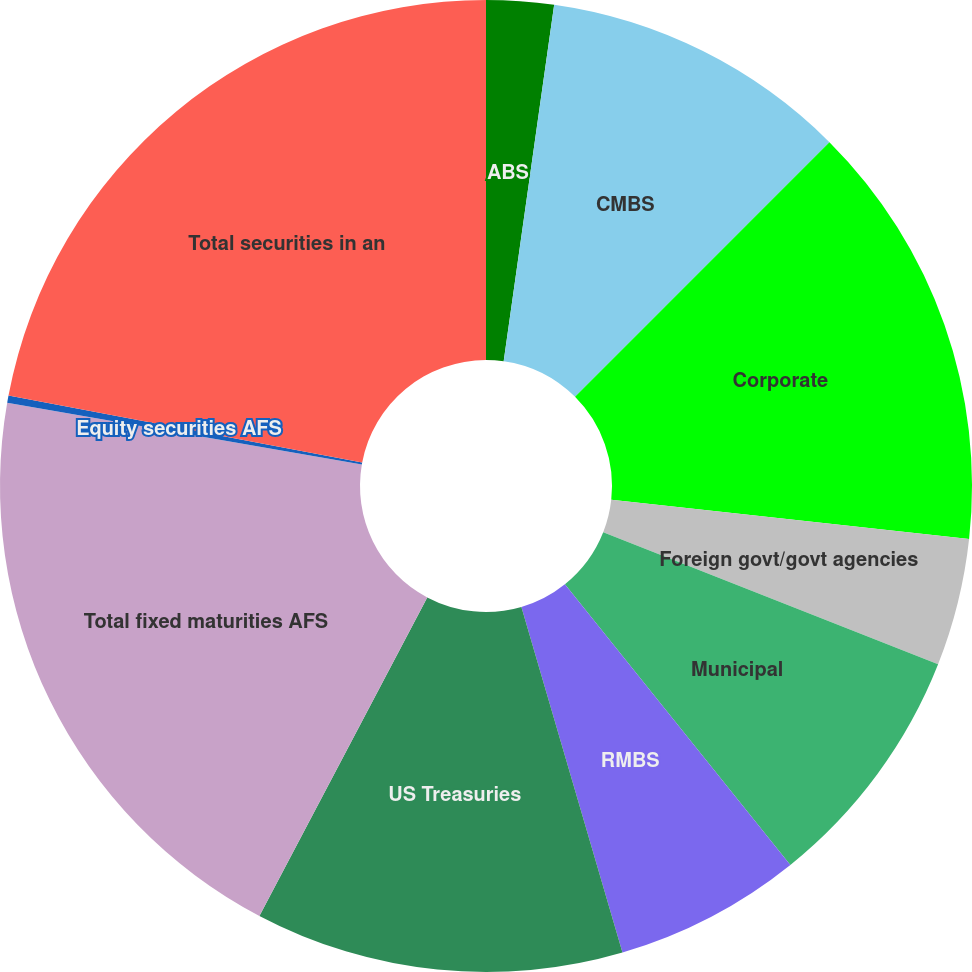Convert chart to OTSL. <chart><loc_0><loc_0><loc_500><loc_500><pie_chart><fcel>ABS<fcel>CMBS<fcel>Corporate<fcel>Foreign govt/govt agencies<fcel>Municipal<fcel>RMBS<fcel>US Treasuries<fcel>Total fixed maturities AFS<fcel>Equity securities AFS<fcel>Total securities in an<nl><fcel>2.24%<fcel>10.25%<fcel>14.25%<fcel>4.24%<fcel>8.25%<fcel>6.24%<fcel>12.25%<fcel>20.02%<fcel>0.24%<fcel>22.02%<nl></chart> 